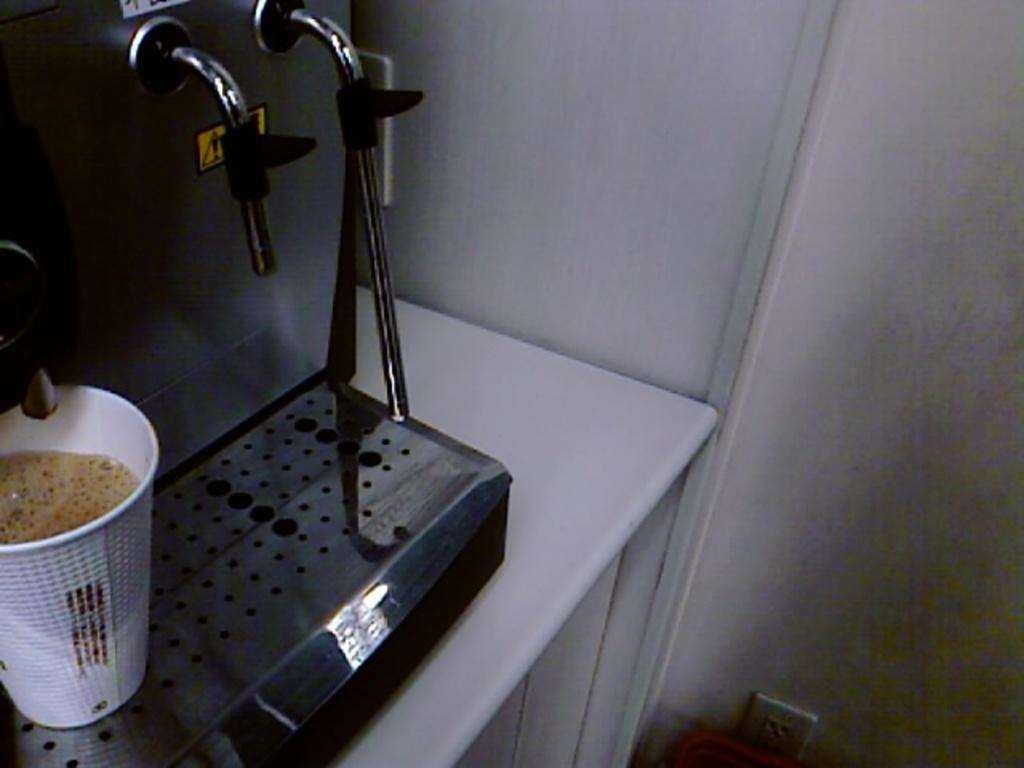Describe this image in one or two sentences. This image is taken indoors. On the right side of the image there is a wall. On the left side of the image there is a table with a coffee machine on it. There is a cup with coffee in it. 